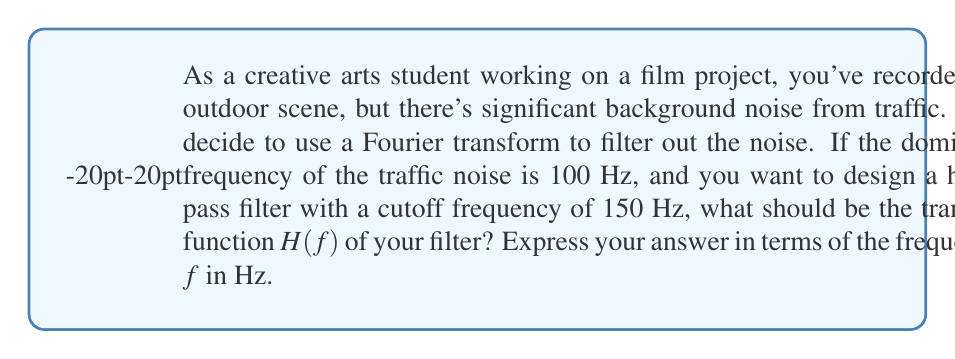Help me with this question. Let's approach this step-by-step:

1) A high-pass filter allows frequencies higher than the cutoff frequency to pass through while attenuating lower frequencies. This is ideal for removing low-frequency noise like traffic sounds.

2) The simplest form of a high-pass filter has a transfer function of the form:

   $$H(f) = \begin{cases} 
   0 & \text{if } f < f_c \\
   1 & \text{if } f \geq f_c
   \end{cases}$$

   where $f_c$ is the cutoff frequency.

3) In this case, $f_c = 150$ Hz.

4) However, this is an ideal filter. In practice, we often use a smoother transition. A common form for a first-order high-pass filter is:

   $$H(f) = \frac{f}{f_c}$$

5) This function gradually increases from 0 as $f$ increases, reaching 1 when $f = f_c$, and continuing to increase for $f > f_c$.

6) To ensure that frequencies well above the cutoff are not amplified too much, we can modify this to:

   $$H(f) = \frac{f}{f_c} \cdot \frac{1}{\sqrt{1 + (\frac{f}{f_c})^2}}$$

7) This function approaches 1 for large $f$, providing a more realistic filter response.

8) Substituting $f_c = 150$ Hz, we get:

   $$H(f) = \frac{f}{150} \cdot \frac{1}{\sqrt{1 + (\frac{f}{150})^2}}$$

This transfer function will effectively attenuate the 100 Hz traffic noise while allowing higher frequencies to pass through.
Answer: $$H(f) = \frac{f}{150} \cdot \frac{1}{\sqrt{1 + (\frac{f}{150})^2}}$$ 